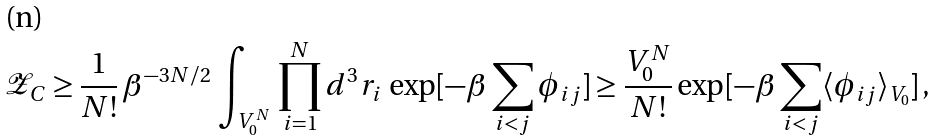Convert formula to latex. <formula><loc_0><loc_0><loc_500><loc_500>\mathcal { Z } _ { C } \geq \frac { 1 } { N ! } \, \beta ^ { - 3 N / 2 } \, \int _ { V _ { 0 } ^ { N } } \, \prod _ { i = 1 } ^ { N } d ^ { 3 } r _ { i } \, \exp [ - \beta \sum _ { i < j } \phi _ { i j } ] \geq \frac { V _ { 0 } ^ { N } } { N ! } \exp [ - \beta \sum _ { i < j } \langle \phi _ { i j } \rangle _ { V _ { 0 } } ] \, ,</formula> 